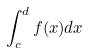<formula> <loc_0><loc_0><loc_500><loc_500>\int _ { c } ^ { d } f ( x ) d x</formula> 